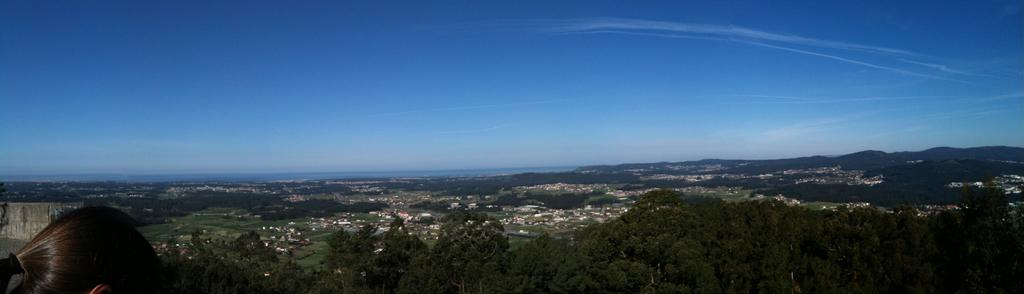What type of vegetation is present in the image? There are trees in the image. Where are the trees located in the image? The trees are on the left side of the image. Who is present in the image? There is a woman in the image. Where is the woman located in the image? The woman is on the left side of the image. What can be seen in the background of the image? The sky is visible in the image. What color is the sky in the image? The sky is blue in the image. Can you hear the music playing in the image? There is no mention of music in the image, so it cannot be heard. Is there a chair visible in the image? There is no mention of a chair in the image, so it cannot be seen. 